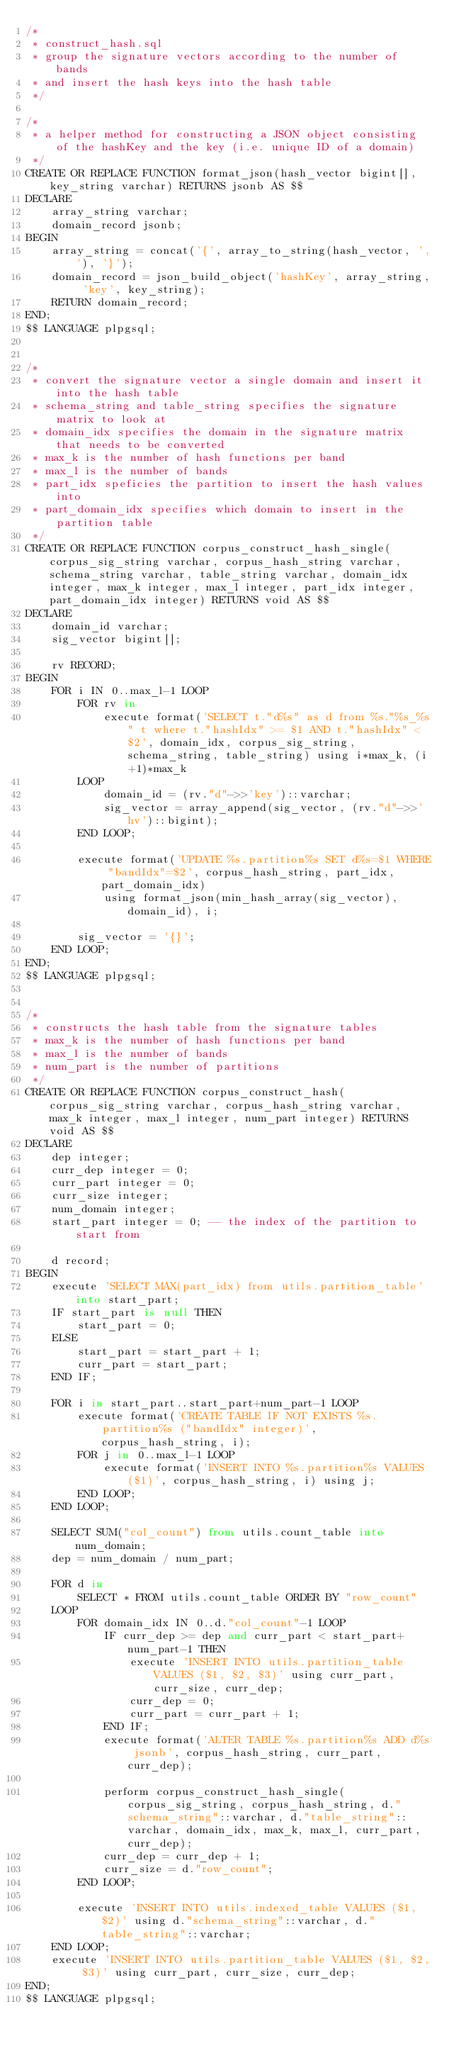<code> <loc_0><loc_0><loc_500><loc_500><_SQL_>/*
 * construct_hash.sql
 * group the signature vectors according to the number of bands
 * and insert the hash keys into the hash table
 */

/*
 * a helper method for constructing a JSON object consisting of the hashKey and the key (i.e. unique ID of a domain)
 */
CREATE OR REPLACE FUNCTION format_json(hash_vector bigint[], key_string varchar) RETURNS jsonb AS $$
DECLARE
	array_string varchar;
	domain_record jsonb;
BEGIN
	array_string = concat('{', array_to_string(hash_vector, ','), '}');
	domain_record = json_build_object('hashKey', array_string, 'key', key_string);
	RETURN domain_record;
END;
$$ LANGUAGE plpgsql;


/*
 * convert the signature vector a single domain and insert it into the hash table
 * schema_string and table_string specifies the signature matrix to look at
 * domain_idx specifies the domain in the signature matrix that needs to be converted
 * max_k is the number of hash functions per band
 * max_l is the number of bands
 * part_idx speficies the partition to insert the hash values into
 * part_domain_idx specifies which domain to insert in the partition table
 */
CREATE OR REPLACE FUNCTION corpus_construct_hash_single(corpus_sig_string varchar, corpus_hash_string varchar, schema_string varchar, table_string varchar, domain_idx integer, max_k integer, max_l integer, part_idx integer, part_domain_idx integer) RETURNS void AS $$
DECLARE
	domain_id varchar;
	sig_vector bigint[];

	rv RECORD;
BEGIN
	FOR i IN 0..max_l-1 LOOP
		FOR rv in
			execute format('SELECT t."d%s" as d from %s."%s_%s" t where t."hashIdx" >= $1 AND t."hashIdx" < $2', domain_idx, corpus_sig_string, schema_string, table_string) using i*max_k, (i+1)*max_k
		LOOP
			domain_id = (rv."d"->>'key')::varchar;
			sig_vector = array_append(sig_vector, (rv."d"->>'hv')::bigint);
		END LOOP;

		execute format('UPDATE %s.partition%s SET d%s=$1 WHERE "bandIdx"=$2', corpus_hash_string, part_idx, part_domain_idx)
			using format_json(min_hash_array(sig_vector), domain_id), i;

		sig_vector = '{}';
	END LOOP;
END;
$$ LANGUAGE plpgsql;


/*
 * constructs the hash table from the signature tables
 * max_k is the number of hash functions per band
 * max_l is the number of bands
 * num_part is the number of partitions
 */
CREATE OR REPLACE FUNCTION corpus_construct_hash(corpus_sig_string varchar, corpus_hash_string varchar, max_k integer, max_l integer, num_part integer) RETURNS void AS $$
DECLARE
	dep integer;
	curr_dep integer = 0;
	curr_part integer = 0;
	curr_size integer;
	num_domain integer;
	start_part integer = 0; -- the index of the partition to start from

	d record;
BEGIN
	execute 'SELECT MAX(part_idx) from utils.partition_table' into start_part;
	IF start_part is null THEN
		start_part = 0;
	ELSE
		start_part = start_part + 1;
		curr_part = start_part;
	END IF;

	FOR i in start_part..start_part+num_part-1 LOOP
		execute format('CREATE TABLE IF NOT EXISTS %s.partition%s ("bandIdx" integer)', corpus_hash_string, i);
		FOR j in 0..max_l-1 LOOP
			execute format('INSERT INTO %s.partition%s VALUES ($1)', corpus_hash_string, i) using j;
		END LOOP;
	END LOOP;

	SELECT SUM("col_count") from utils.count_table into num_domain;
	dep = num_domain / num_part;

	FOR d in
		SELECT * FROM utils.count_table ORDER BY "row_count"
	LOOP
		FOR domain_idx IN 0..d."col_count"-1 LOOP
			IF curr_dep >= dep and curr_part < start_part+num_part-1 THEN
				execute 'INSERT INTO utils.partition_table VALUES ($1, $2, $3)' using curr_part, curr_size, curr_dep;
				curr_dep = 0;
				curr_part = curr_part + 1;
			END IF;
			execute format('ALTER TABLE %s.partition%s ADD d%s jsonb', corpus_hash_string, curr_part, curr_dep);

			perform corpus_construct_hash_single(corpus_sig_string, corpus_hash_string, d."schema_string"::varchar, d."table_string"::varchar, domain_idx, max_k, max_l, curr_part, curr_dep);
			curr_dep = curr_dep + 1;
			curr_size = d."row_count";
		END LOOP;

		execute 'INSERT INTO utils.indexed_table VALUES ($1, $2)' using d."schema_string"::varchar, d."table_string"::varchar;
	END LOOP;
	execute 'INSERT INTO utils.partition_table VALUES ($1, $2, $3)' using curr_part, curr_size, curr_dep;
END;
$$ LANGUAGE plpgsql;</code> 